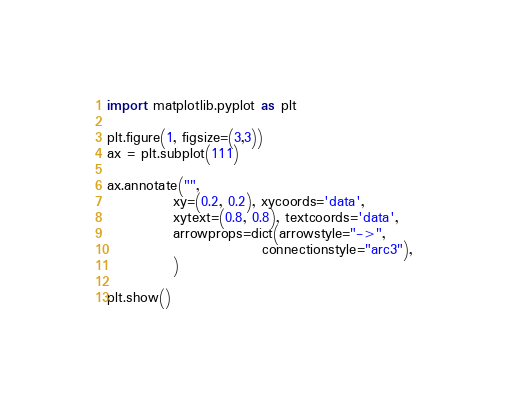<code> <loc_0><loc_0><loc_500><loc_500><_Python_>import matplotlib.pyplot as plt

plt.figure(1, figsize=(3,3))
ax = plt.subplot(111)

ax.annotate("",
            xy=(0.2, 0.2), xycoords='data',
            xytext=(0.8, 0.8), textcoords='data',
            arrowprops=dict(arrowstyle="->",
                            connectionstyle="arc3"), 
            )

plt.show()

</code> 